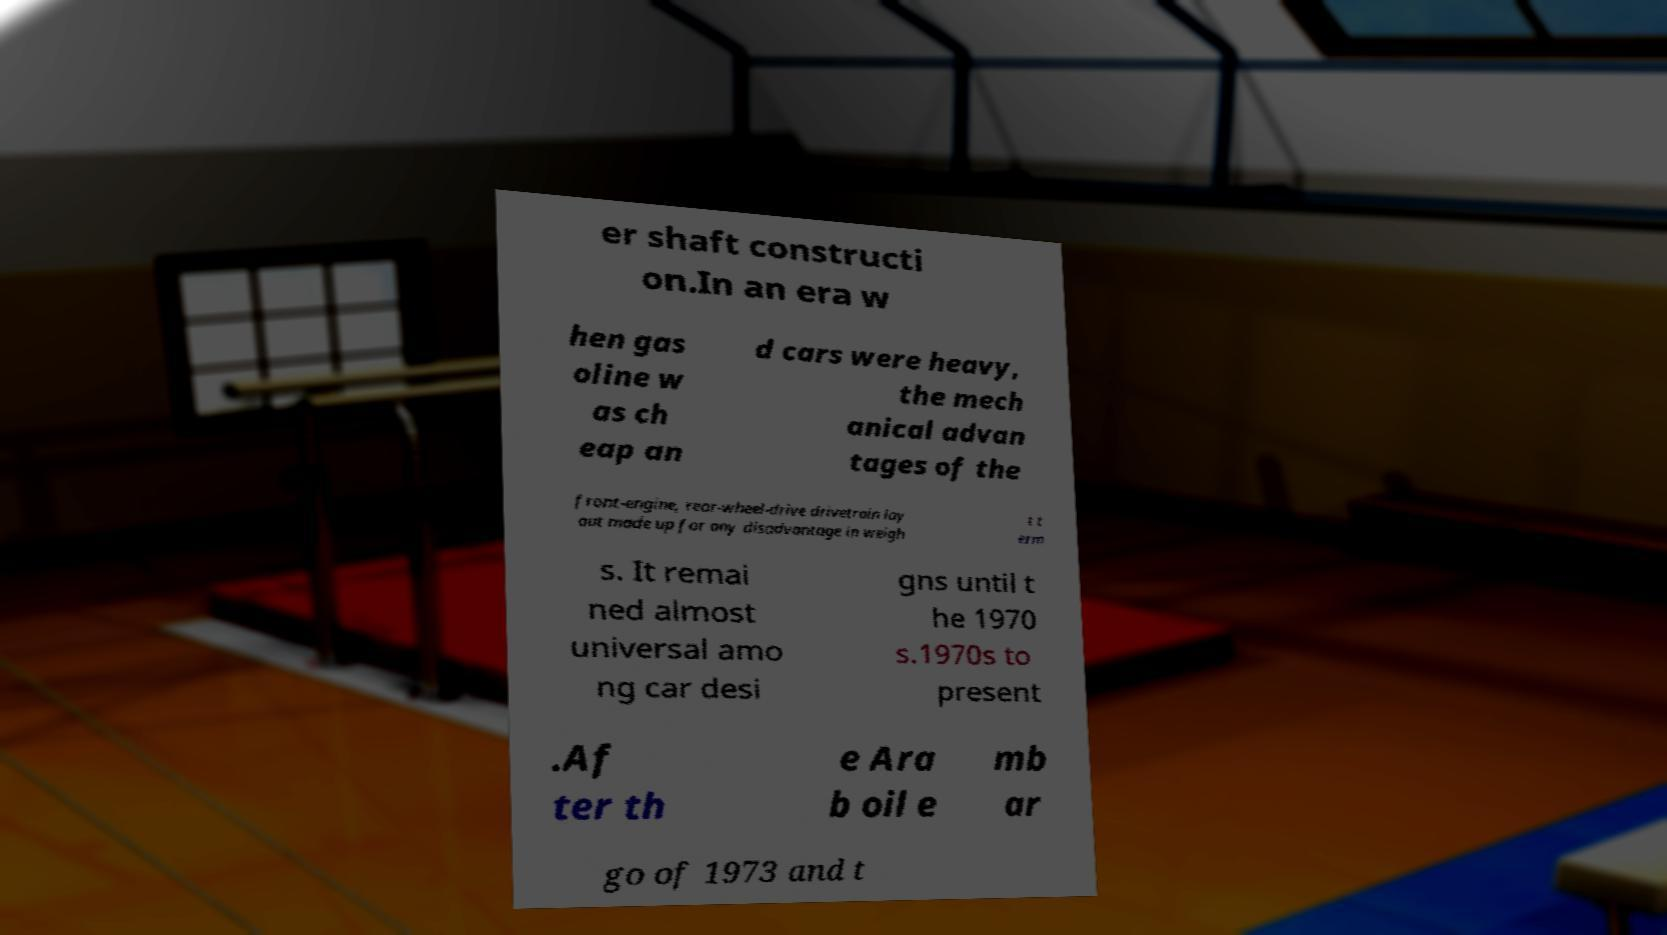For documentation purposes, I need the text within this image transcribed. Could you provide that? er shaft constructi on.In an era w hen gas oline w as ch eap an d cars were heavy, the mech anical advan tages of the front-engine, rear-wheel-drive drivetrain lay out made up for any disadvantage in weigh t t erm s. It remai ned almost universal amo ng car desi gns until t he 1970 s.1970s to present .Af ter th e Ara b oil e mb ar go of 1973 and t 